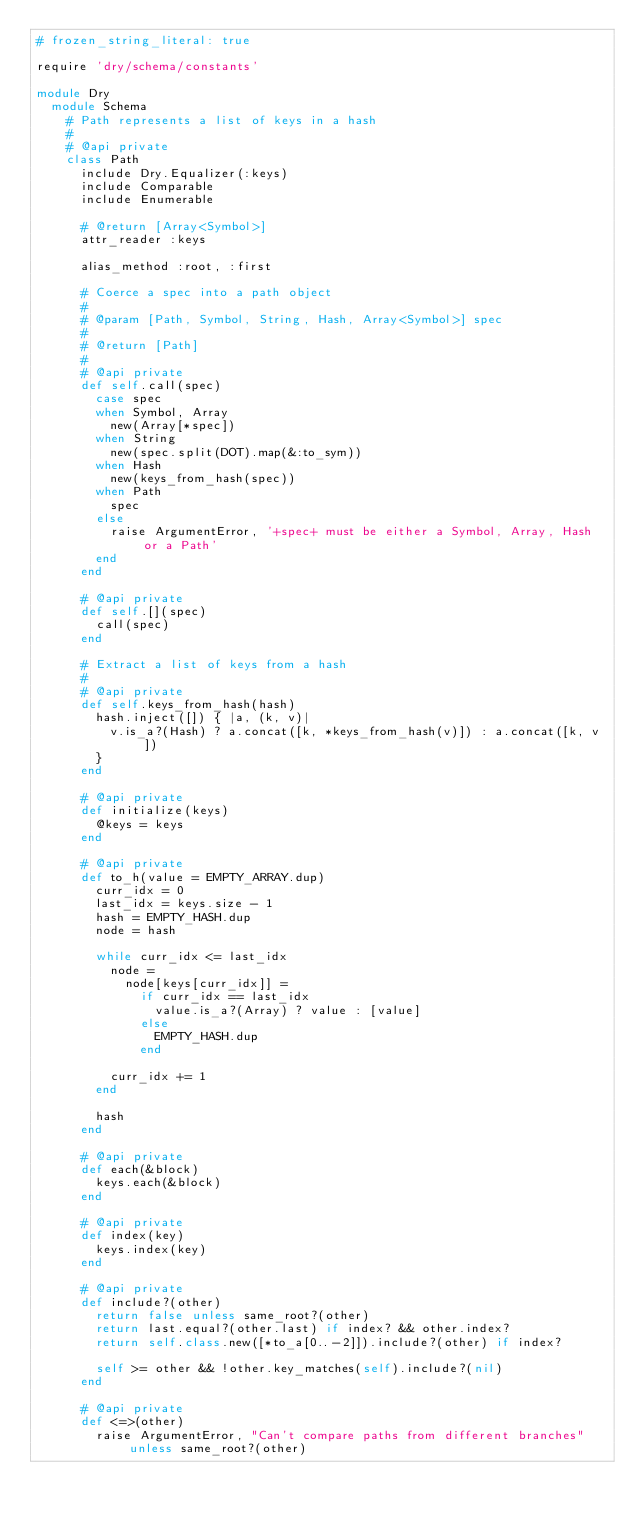Convert code to text. <code><loc_0><loc_0><loc_500><loc_500><_Ruby_># frozen_string_literal: true

require 'dry/schema/constants'

module Dry
  module Schema
    # Path represents a list of keys in a hash
    #
    # @api private
    class Path
      include Dry.Equalizer(:keys)
      include Comparable
      include Enumerable

      # @return [Array<Symbol>]
      attr_reader :keys

      alias_method :root, :first

      # Coerce a spec into a path object
      #
      # @param [Path, Symbol, String, Hash, Array<Symbol>] spec
      #
      # @return [Path]
      #
      # @api private
      def self.call(spec)
        case spec
        when Symbol, Array
          new(Array[*spec])
        when String
          new(spec.split(DOT).map(&:to_sym))
        when Hash
          new(keys_from_hash(spec))
        when Path
          spec
        else
          raise ArgumentError, '+spec+ must be either a Symbol, Array, Hash or a Path'
        end
      end

      # @api private
      def self.[](spec)
        call(spec)
      end

      # Extract a list of keys from a hash
      #
      # @api private
      def self.keys_from_hash(hash)
        hash.inject([]) { |a, (k, v)|
          v.is_a?(Hash) ? a.concat([k, *keys_from_hash(v)]) : a.concat([k, v])
        }
      end

      # @api private
      def initialize(keys)
        @keys = keys
      end

      # @api private
      def to_h(value = EMPTY_ARRAY.dup)
        curr_idx = 0
        last_idx = keys.size - 1
        hash = EMPTY_HASH.dup
        node = hash

        while curr_idx <= last_idx
          node =
            node[keys[curr_idx]] =
              if curr_idx == last_idx
                value.is_a?(Array) ? value : [value]
              else
                EMPTY_HASH.dup
              end

          curr_idx += 1
        end

        hash
      end

      # @api private
      def each(&block)
        keys.each(&block)
      end

      # @api private
      def index(key)
        keys.index(key)
      end

      # @api private
      def include?(other)
        return false unless same_root?(other)
        return last.equal?(other.last) if index? && other.index?
        return self.class.new([*to_a[0..-2]]).include?(other) if index?

        self >= other && !other.key_matches(self).include?(nil)
      end

      # @api private
      def <=>(other)
        raise ArgumentError, "Can't compare paths from different branches" unless same_root?(other)
</code> 